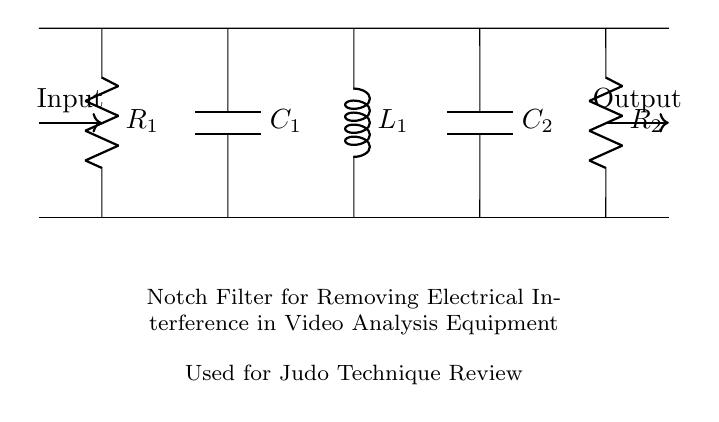What is the type of filter used in this circuit? The circuit diagram shows a notch filter, designed specifically to remove electrical interference from the signal output. The components used and their arrangement are characteristic of a notch filter's configuration.
Answer: Notch filter How many resistors are present in the circuit? Upon examining the circuit diagram, there are two resistors identified (R1 and R2) connected in the specified arrangement.
Answer: Two What is the purpose of this notch filter? The primary purpose of this notch filter is to eliminate electrical interference, particularly within the context of video analysis equipment used for technique review in judo. This purpose is explicitly indicated in the annotations below the circuit.
Answer: Remove electrical interference Which component is in series with capacitor C1? Looking at the circuit, capacitor C1 is in series with resistor R1, as they are aligned vertically in sequence and directly connected.
Answer: Resistor R1 What is the function of inductor L1 in the circuit? Inductor L1 plays a crucial role in the frequency response of the notch filter, allowing it to attenuate specific frequencies while passing others. The interaction with the capacitors and resistors shapes this function.
Answer: Attenuate specific frequencies What is the total number of reactive components in the circuit? The circuit consists of two capacitors (C1 and C2) and one inductor (L1), which are all considered reactive components. Adding these together gives us the total number of reactive components.
Answer: Three What is the input direction in this circuit? According to the diagram, the input direction is clearly illustrated with an arrow pointing from left to right, indicating the flow of the electrical signal entering the filter from the input side.
Answer: Left to right 